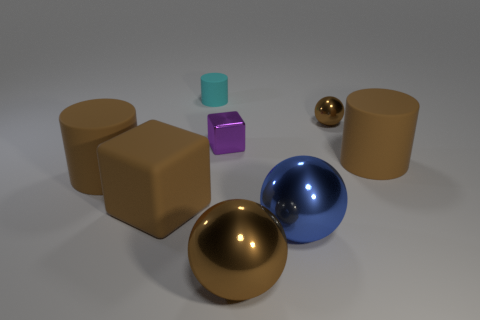Add 2 tiny brown metallic things. How many objects exist? 10 Subtract all brown metallic spheres. How many spheres are left? 1 Subtract 1 cylinders. How many cylinders are left? 2 Subtract all spheres. How many objects are left? 5 Subtract all yellow rubber balls. Subtract all blue metallic things. How many objects are left? 7 Add 2 purple objects. How many purple objects are left? 3 Add 8 large cyan shiny cubes. How many large cyan shiny cubes exist? 8 Subtract all brown blocks. How many blocks are left? 1 Subtract 0 gray cubes. How many objects are left? 8 Subtract all yellow cylinders. Subtract all blue balls. How many cylinders are left? 3 